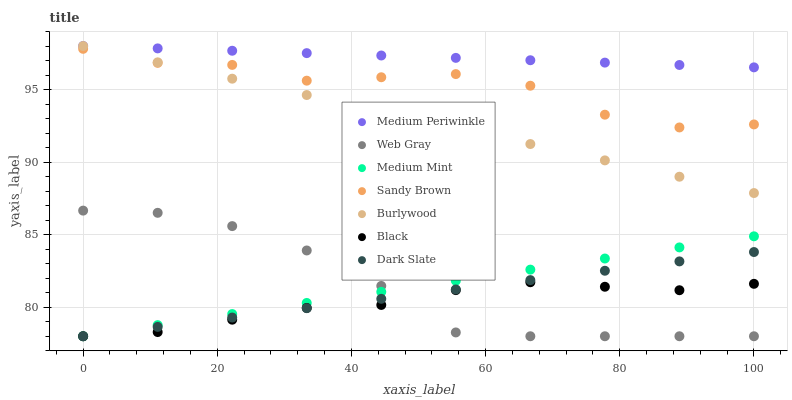Does Black have the minimum area under the curve?
Answer yes or no. Yes. Does Medium Periwinkle have the maximum area under the curve?
Answer yes or no. Yes. Does Web Gray have the minimum area under the curve?
Answer yes or no. No. Does Web Gray have the maximum area under the curve?
Answer yes or no. No. Is Dark Slate the smoothest?
Answer yes or no. Yes. Is Sandy Brown the roughest?
Answer yes or no. Yes. Is Web Gray the smoothest?
Answer yes or no. No. Is Web Gray the roughest?
Answer yes or no. No. Does Medium Mint have the lowest value?
Answer yes or no. Yes. Does Burlywood have the lowest value?
Answer yes or no. No. Does Medium Periwinkle have the highest value?
Answer yes or no. Yes. Does Web Gray have the highest value?
Answer yes or no. No. Is Dark Slate less than Medium Periwinkle?
Answer yes or no. Yes. Is Medium Periwinkle greater than Sandy Brown?
Answer yes or no. Yes. Does Black intersect Medium Mint?
Answer yes or no. Yes. Is Black less than Medium Mint?
Answer yes or no. No. Is Black greater than Medium Mint?
Answer yes or no. No. Does Dark Slate intersect Medium Periwinkle?
Answer yes or no. No. 